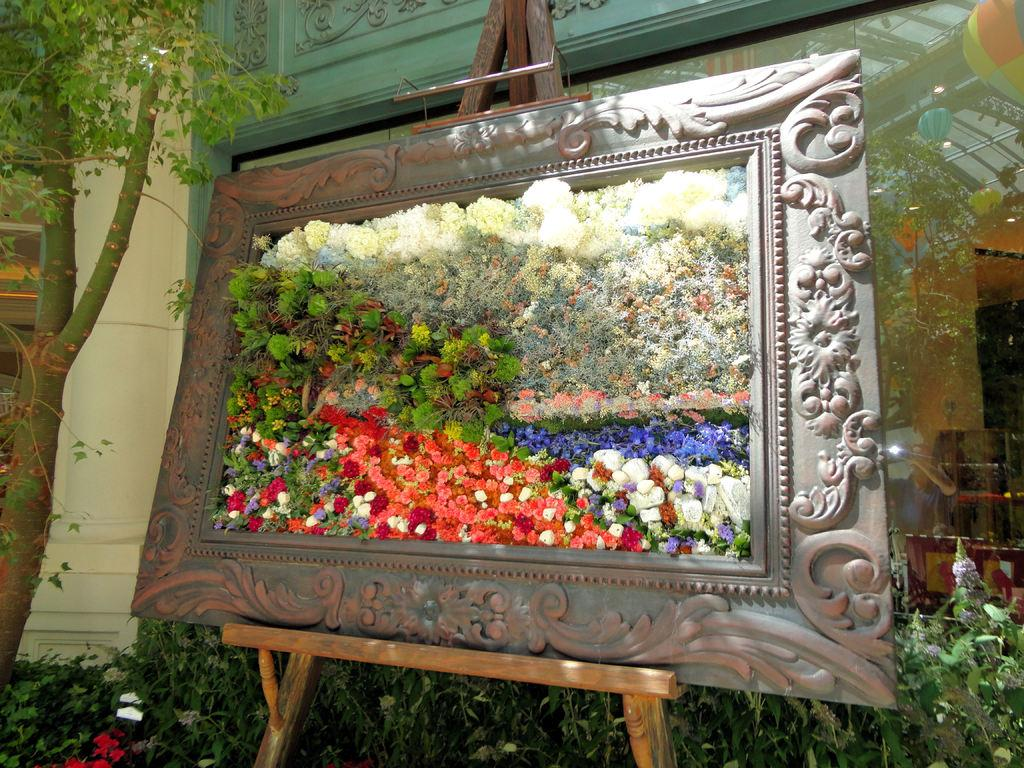What is the main object in the center of the image? There is a board in the center of the image. What type of flora can be seen in the image? There are flowers in the image. What can be seen in the background of the image? There is a building, plants, a tree, and a pillar in the background of the image. Are there any other objects visible in the background? Yes, there are other objects in the background of the image. What type of needle is being used to grip the wall in the image? There is no needle or wall present in the image. How many grips are visible on the wall in the image? There is no wall or grips present in the image. 